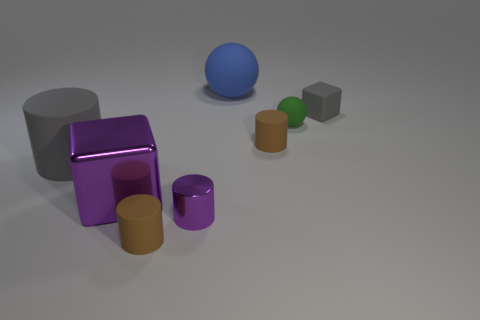What number of other objects are the same material as the blue thing?
Your answer should be very brief. 5. How many blue matte objects are in front of the small purple thing?
Make the answer very short. 0. What number of cylinders are either big purple metallic things or blue matte things?
Your answer should be very brief. 0. There is a object that is both in front of the green sphere and on the right side of the purple cylinder; what size is it?
Keep it short and to the point. Small. What number of other things are the same color as the small ball?
Your answer should be very brief. 0. Is the material of the large gray cylinder the same as the block left of the tiny gray cube?
Your response must be concise. No. How many things are either small brown cylinders that are in front of the gray cylinder or green metal cylinders?
Your response must be concise. 1. What is the shape of the object that is both behind the green matte object and left of the gray matte block?
Ensure brevity in your answer.  Sphere. Is there anything else that has the same size as the purple metallic block?
Offer a terse response. Yes. What size is the blue sphere that is the same material as the tiny block?
Make the answer very short. Large. 